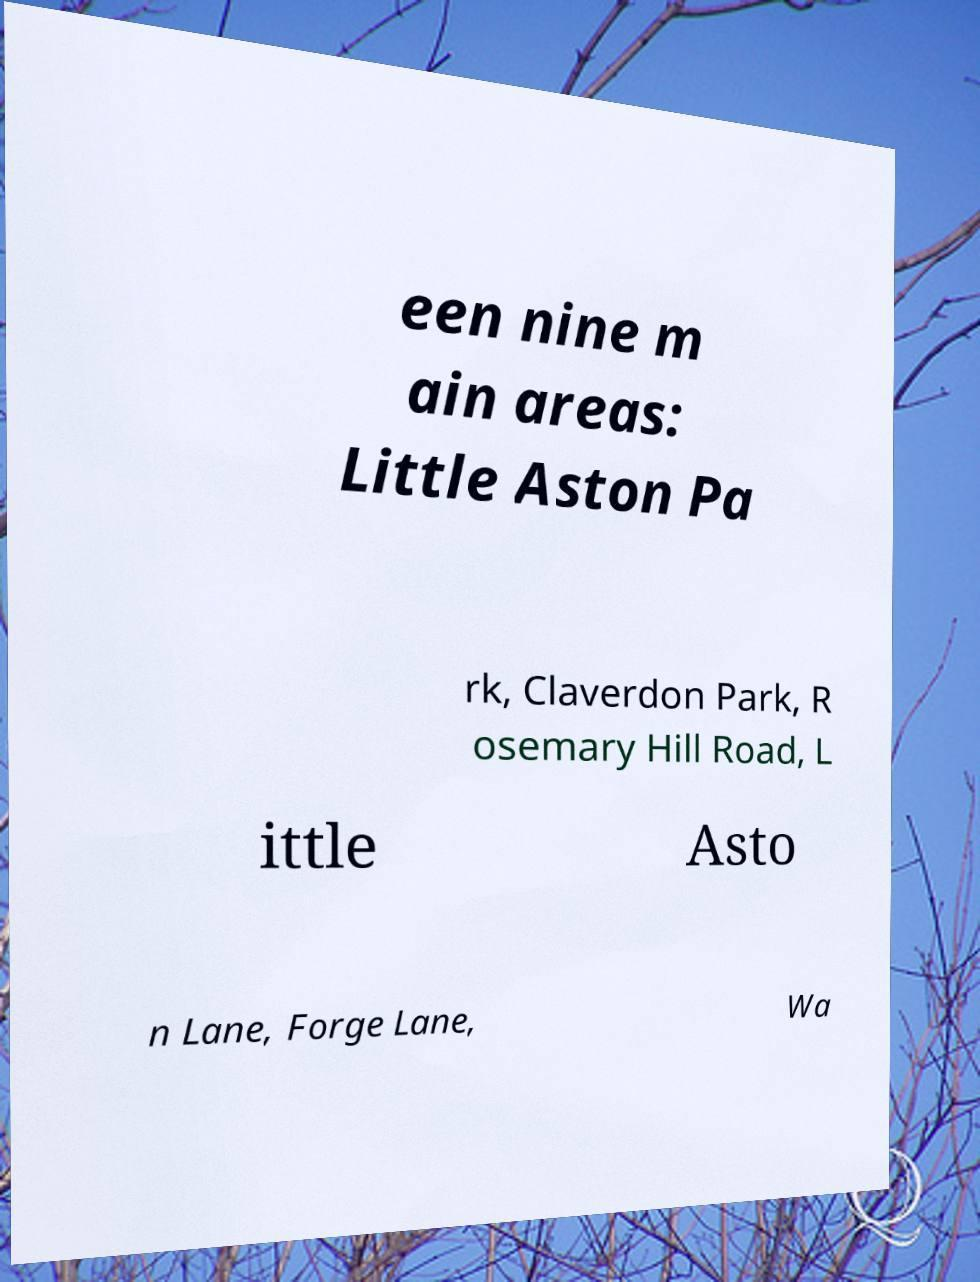Can you accurately transcribe the text from the provided image for me? een nine m ain areas: Little Aston Pa rk, Claverdon Park, R osemary Hill Road, L ittle Asto n Lane, Forge Lane, Wa 